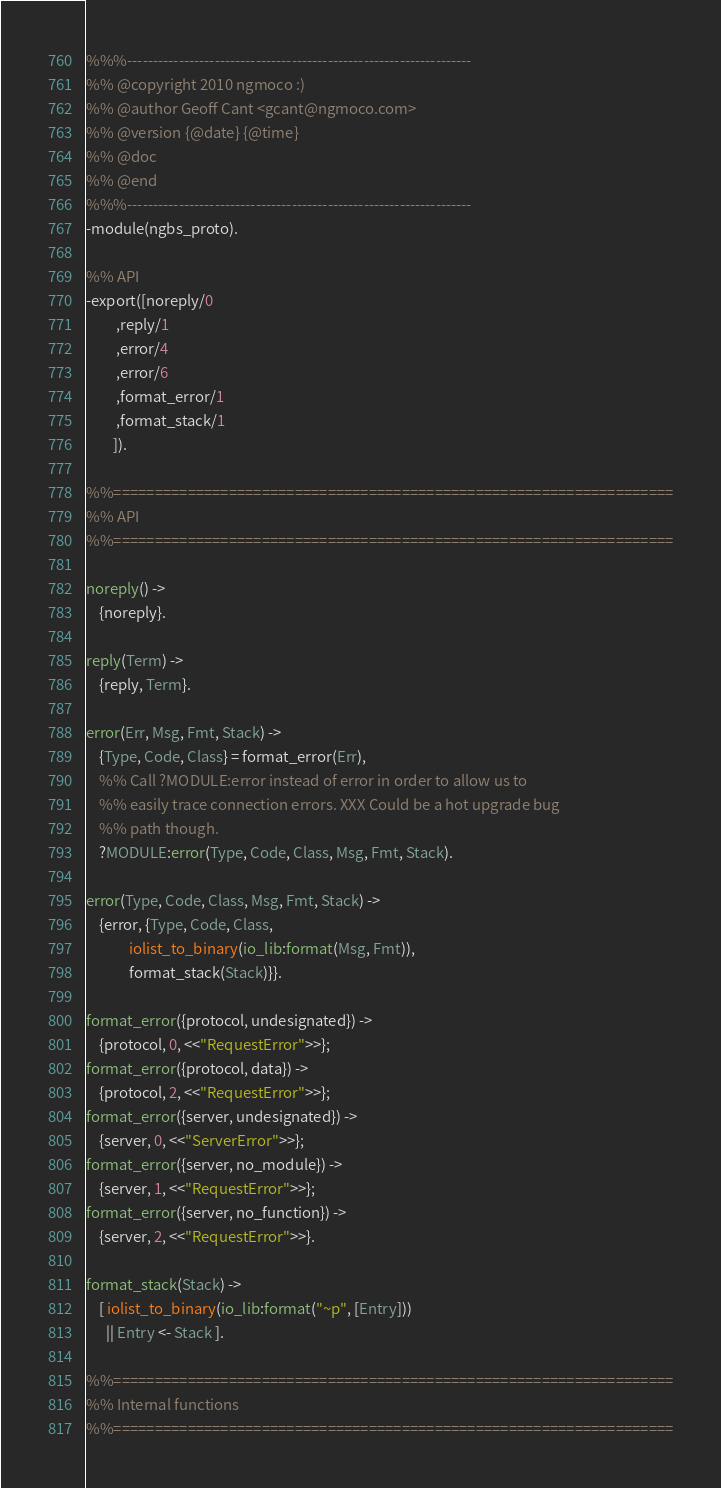Convert code to text. <code><loc_0><loc_0><loc_500><loc_500><_Erlang_>%%%-------------------------------------------------------------------
%% @copyright 2010 ngmoco :)
%% @author Geoff Cant <gcant@ngmoco.com>
%% @version {@date} {@time}
%% @doc 
%% @end
%%%-------------------------------------------------------------------
-module(ngbs_proto).

%% API
-export([noreply/0
         ,reply/1
         ,error/4
         ,error/6
         ,format_error/1
         ,format_stack/1
        ]).

%%====================================================================
%% API
%%====================================================================

noreply() ->
    {noreply}.

reply(Term) ->
    {reply, Term}.

error(Err, Msg, Fmt, Stack) ->
    {Type, Code, Class} = format_error(Err),
    %% Call ?MODULE:error instead of error in order to allow us to
    %% easily trace connection errors. XXX Could be a hot upgrade bug
    %% path though.
    ?MODULE:error(Type, Code, Class, Msg, Fmt, Stack).

error(Type, Code, Class, Msg, Fmt, Stack) ->
    {error, {Type, Code, Class,
             iolist_to_binary(io_lib:format(Msg, Fmt)),
             format_stack(Stack)}}.
                            
format_error({protocol, undesignated}) ->
    {protocol, 0, <<"RequestError">>};
format_error({protocol, data}) ->
    {protocol, 2, <<"RequestError">>};
format_error({server, undesignated}) ->
    {server, 0, <<"ServerError">>};
format_error({server, no_module}) ->
    {server, 1, <<"RequestError">>};
format_error({server, no_function}) ->
    {server, 2, <<"RequestError">>}.

format_stack(Stack) ->
    [ iolist_to_binary(io_lib:format("~p", [Entry]))
      || Entry <- Stack ].

%%====================================================================
%% Internal functions
%%====================================================================
</code> 